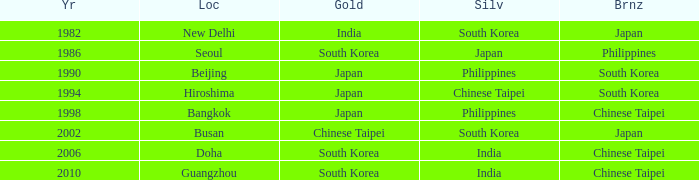Which Year is the highest one that has a Bronze of south korea, and a Silver of philippines? 1990.0. 